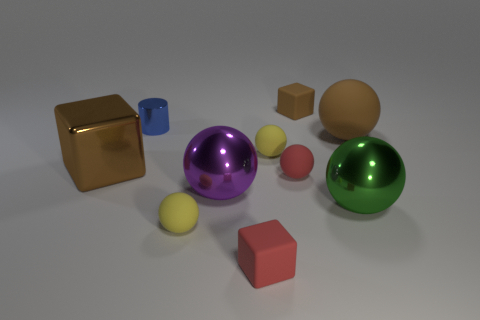Subtract all yellow spheres. How many were subtracted if there are1yellow spheres left? 1 Subtract all green balls. How many balls are left? 5 Subtract all brown cubes. How many cubes are left? 1 Subtract all cylinders. How many objects are left? 9 Subtract all blue balls. How many brown cubes are left? 2 Subtract 0 green blocks. How many objects are left? 10 Subtract 1 spheres. How many spheres are left? 5 Subtract all gray cubes. Subtract all brown cylinders. How many cubes are left? 3 Subtract all small spheres. Subtract all purple metal balls. How many objects are left? 6 Add 2 big blocks. How many big blocks are left? 3 